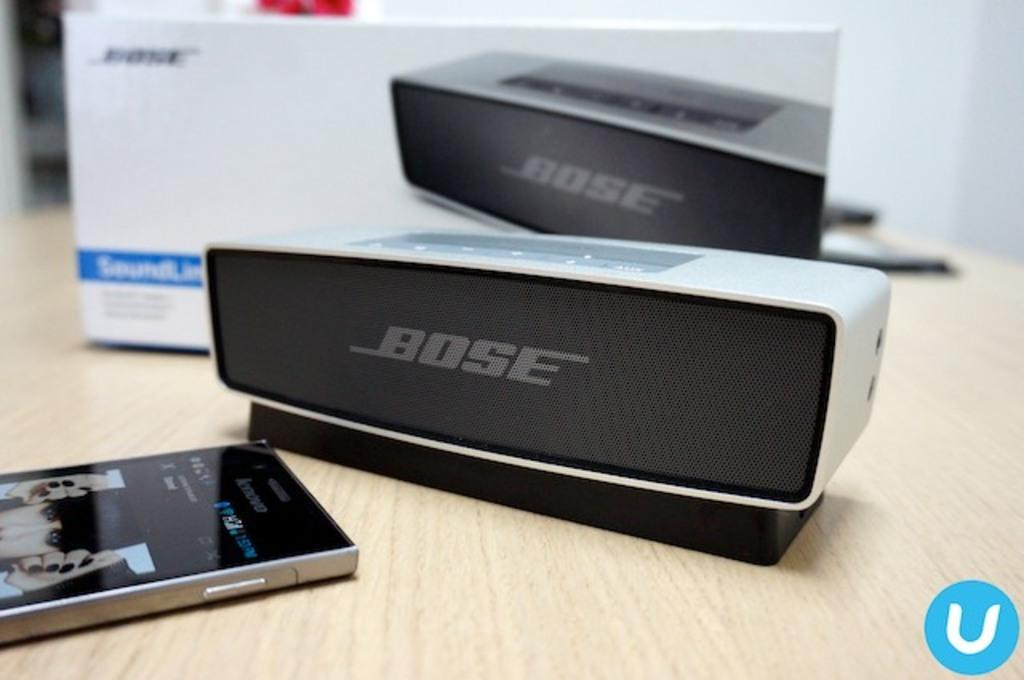What electronic device can be seen in the image? There is a mobile phone in the image. What is the other electronic device present in the image? There is a speaker in the image. What is the speaker's box used for? The speaker's box is present in the image to house the speaker. Where are all the items located in the image? All items are on a table. How many hills can be seen in the image? There are no hills present in the image. What is the rate of the mobile phone's battery life in the image? The image does not provide information about the mobile phone's battery life, so it cannot be determined. 